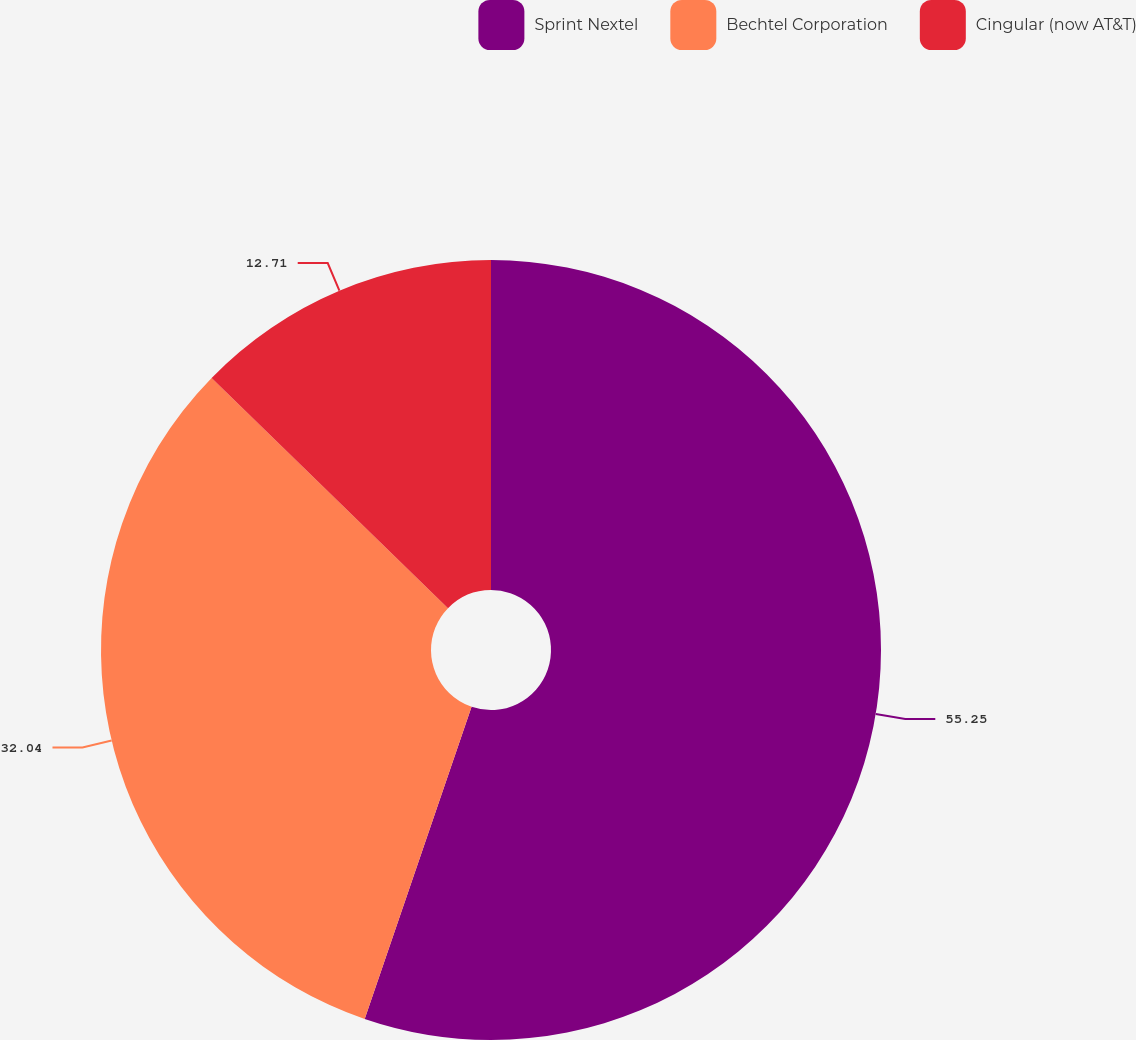<chart> <loc_0><loc_0><loc_500><loc_500><pie_chart><fcel>Sprint Nextel<fcel>Bechtel Corporation<fcel>Cingular (now AT&T)<nl><fcel>55.25%<fcel>32.04%<fcel>12.71%<nl></chart> 